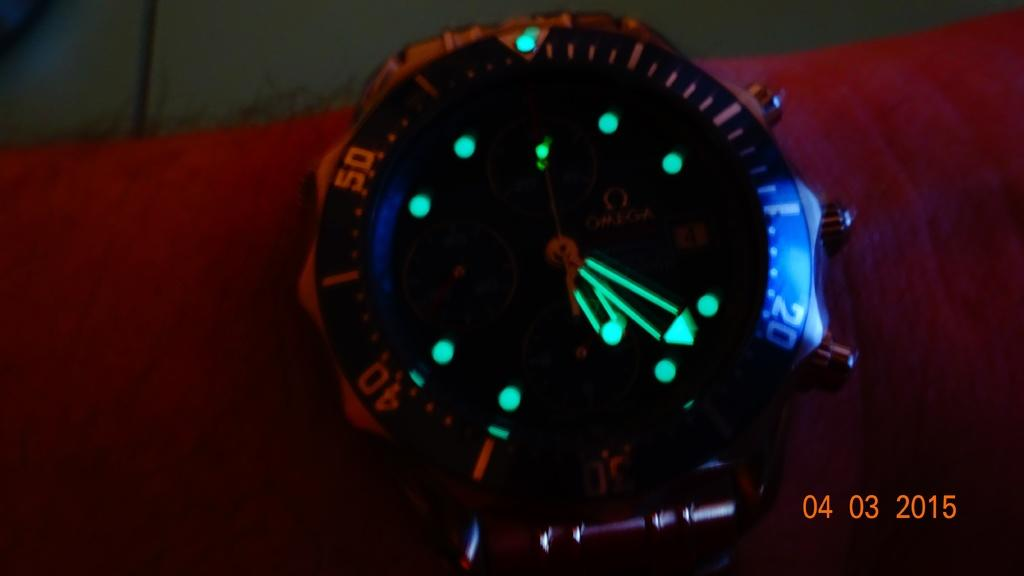<image>
Relay a brief, clear account of the picture shown. A photograph taken on April 3, 2015 shows a watch with glow in the dark hands. 